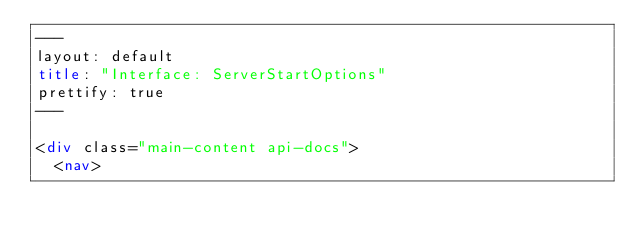Convert code to text. <code><loc_0><loc_0><loc_500><loc_500><_HTML_>---
layout: default
title: "Interface: ServerStartOptions"
prettify: true
---

<div class="main-content api-docs">
  <nav></code> 